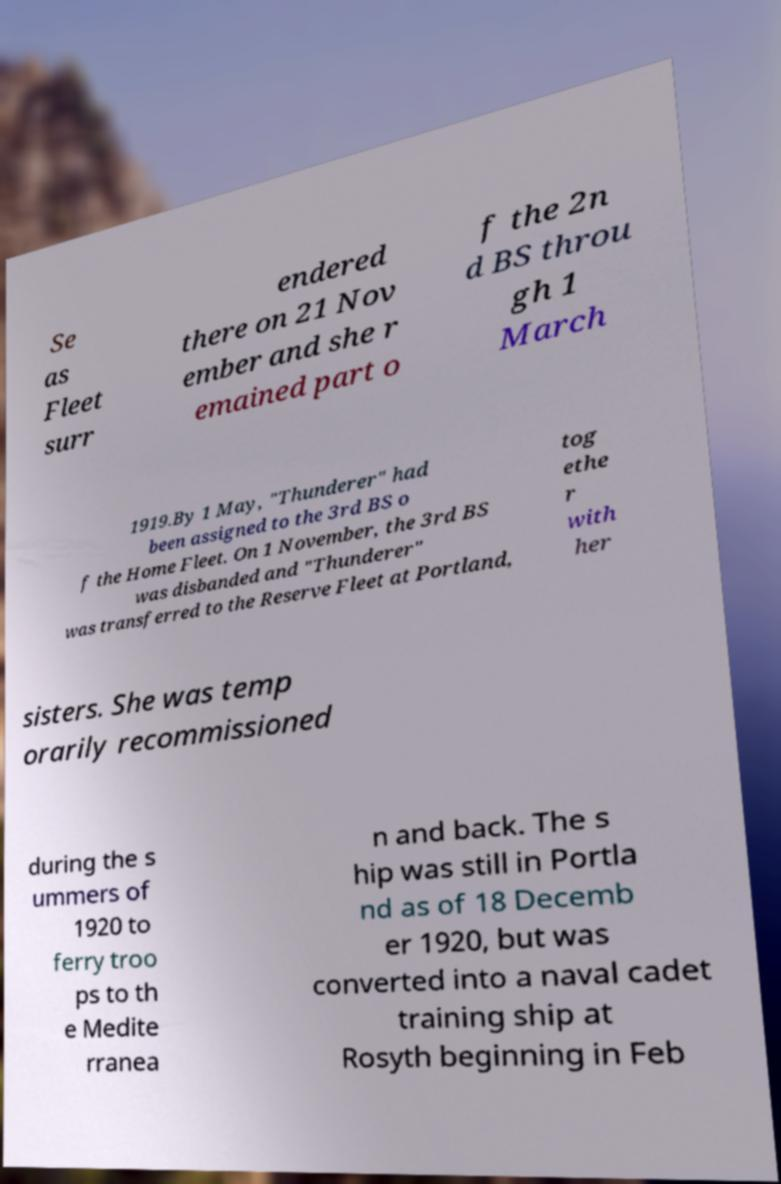What messages or text are displayed in this image? I need them in a readable, typed format. Se as Fleet surr endered there on 21 Nov ember and she r emained part o f the 2n d BS throu gh 1 March 1919.By 1 May, "Thunderer" had been assigned to the 3rd BS o f the Home Fleet. On 1 November, the 3rd BS was disbanded and "Thunderer" was transferred to the Reserve Fleet at Portland, tog ethe r with her sisters. She was temp orarily recommissioned during the s ummers of 1920 to ferry troo ps to th e Medite rranea n and back. The s hip was still in Portla nd as of 18 Decemb er 1920, but was converted into a naval cadet training ship at Rosyth beginning in Feb 